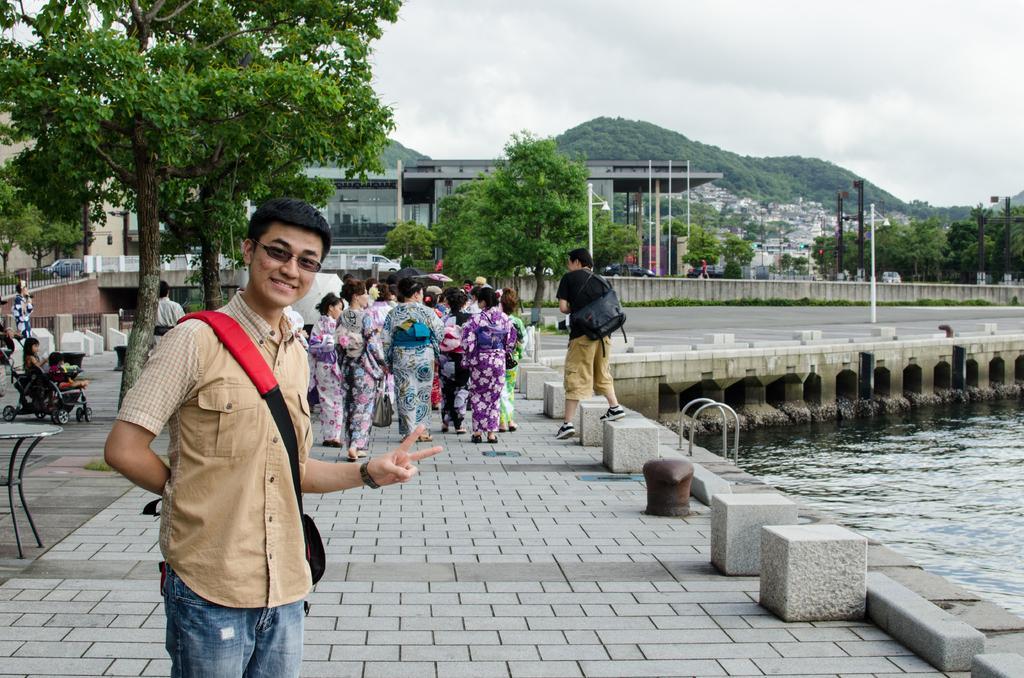Describe this image in one or two sentences. In this picture there is a person standing and smiling. At the back there are group of people walking. On the left side of the image there is a person sitting and there is a table. At the back there are buildings, trees, poles and there are vehicles on the road. There are trees on the mountain. At the top there are clouds. At the bottom there is water. 